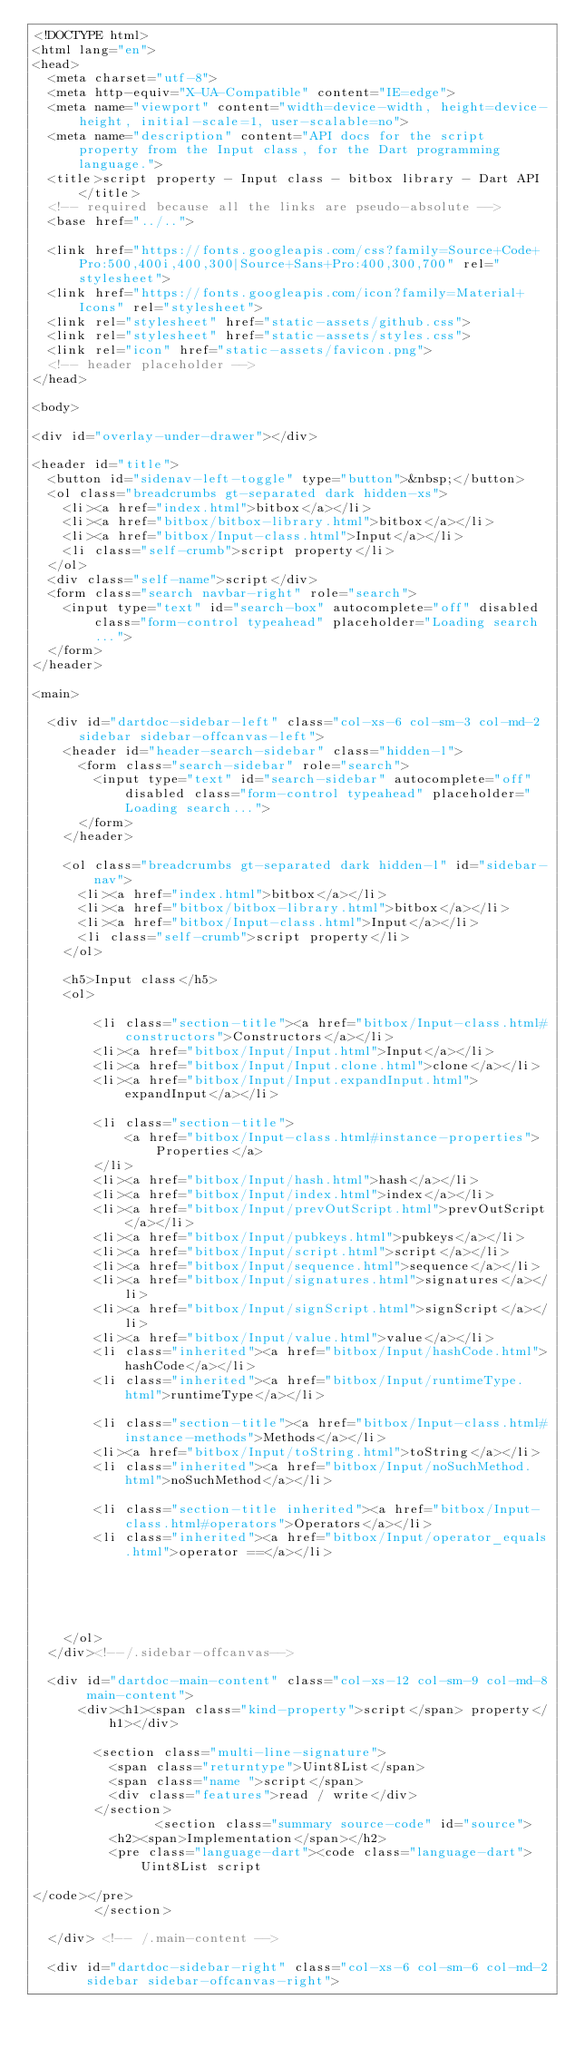Convert code to text. <code><loc_0><loc_0><loc_500><loc_500><_HTML_><!DOCTYPE html>
<html lang="en">
<head>
  <meta charset="utf-8">
  <meta http-equiv="X-UA-Compatible" content="IE=edge">
  <meta name="viewport" content="width=device-width, height=device-height, initial-scale=1, user-scalable=no">
  <meta name="description" content="API docs for the script property from the Input class, for the Dart programming language.">
  <title>script property - Input class - bitbox library - Dart API</title>
  <!-- required because all the links are pseudo-absolute -->
  <base href="../..">

  <link href="https://fonts.googleapis.com/css?family=Source+Code+Pro:500,400i,400,300|Source+Sans+Pro:400,300,700" rel="stylesheet">
  <link href="https://fonts.googleapis.com/icon?family=Material+Icons" rel="stylesheet">
  <link rel="stylesheet" href="static-assets/github.css">
  <link rel="stylesheet" href="static-assets/styles.css">
  <link rel="icon" href="static-assets/favicon.png">
  <!-- header placeholder -->
</head>

<body>

<div id="overlay-under-drawer"></div>

<header id="title">
  <button id="sidenav-left-toggle" type="button">&nbsp;</button>
  <ol class="breadcrumbs gt-separated dark hidden-xs">
    <li><a href="index.html">bitbox</a></li>
    <li><a href="bitbox/bitbox-library.html">bitbox</a></li>
    <li><a href="bitbox/Input-class.html">Input</a></li>
    <li class="self-crumb">script property</li>
  </ol>
  <div class="self-name">script</div>
  <form class="search navbar-right" role="search">
    <input type="text" id="search-box" autocomplete="off" disabled class="form-control typeahead" placeholder="Loading search...">
  </form>
</header>

<main>

  <div id="dartdoc-sidebar-left" class="col-xs-6 col-sm-3 col-md-2 sidebar sidebar-offcanvas-left">
    <header id="header-search-sidebar" class="hidden-l">
      <form class="search-sidebar" role="search">
        <input type="text" id="search-sidebar" autocomplete="off" disabled class="form-control typeahead" placeholder="Loading search...">
      </form>
    </header>
    
    <ol class="breadcrumbs gt-separated dark hidden-l" id="sidebar-nav">
      <li><a href="index.html">bitbox</a></li>
      <li><a href="bitbox/bitbox-library.html">bitbox</a></li>
      <li><a href="bitbox/Input-class.html">Input</a></li>
      <li class="self-crumb">script property</li>
    </ol>
    
    <h5>Input class</h5>
    <ol>
    
        <li class="section-title"><a href="bitbox/Input-class.html#constructors">Constructors</a></li>
        <li><a href="bitbox/Input/Input.html">Input</a></li>
        <li><a href="bitbox/Input/Input.clone.html">clone</a></li>
        <li><a href="bitbox/Input/Input.expandInput.html">expandInput</a></li>
    
        <li class="section-title">
            <a href="bitbox/Input-class.html#instance-properties">Properties</a>
        </li>
        <li><a href="bitbox/Input/hash.html">hash</a></li>
        <li><a href="bitbox/Input/index.html">index</a></li>
        <li><a href="bitbox/Input/prevOutScript.html">prevOutScript</a></li>
        <li><a href="bitbox/Input/pubkeys.html">pubkeys</a></li>
        <li><a href="bitbox/Input/script.html">script</a></li>
        <li><a href="bitbox/Input/sequence.html">sequence</a></li>
        <li><a href="bitbox/Input/signatures.html">signatures</a></li>
        <li><a href="bitbox/Input/signScript.html">signScript</a></li>
        <li><a href="bitbox/Input/value.html">value</a></li>
        <li class="inherited"><a href="bitbox/Input/hashCode.html">hashCode</a></li>
        <li class="inherited"><a href="bitbox/Input/runtimeType.html">runtimeType</a></li>
    
        <li class="section-title"><a href="bitbox/Input-class.html#instance-methods">Methods</a></li>
        <li><a href="bitbox/Input/toString.html">toString</a></li>
        <li class="inherited"><a href="bitbox/Input/noSuchMethod.html">noSuchMethod</a></li>
    
        <li class="section-title inherited"><a href="bitbox/Input-class.html#operators">Operators</a></li>
        <li class="inherited"><a href="bitbox/Input/operator_equals.html">operator ==</a></li>
    
    
    
    
    
    </ol>
  </div><!--/.sidebar-offcanvas-->

  <div id="dartdoc-main-content" class="col-xs-12 col-sm-9 col-md-8 main-content">
      <div><h1><span class="kind-property">script</span> property</h1></div>

        <section class="multi-line-signature">
          <span class="returntype">Uint8List</span>
          <span class="name ">script</span>
          <div class="features">read / write</div>
        </section>
                <section class="summary source-code" id="source">
          <h2><span>Implementation</span></h2>
          <pre class="language-dart"><code class="language-dart">Uint8List script

</code></pre>
        </section>

  </div> <!-- /.main-content -->

  <div id="dartdoc-sidebar-right" class="col-xs-6 col-sm-6 col-md-2 sidebar sidebar-offcanvas-right"></code> 